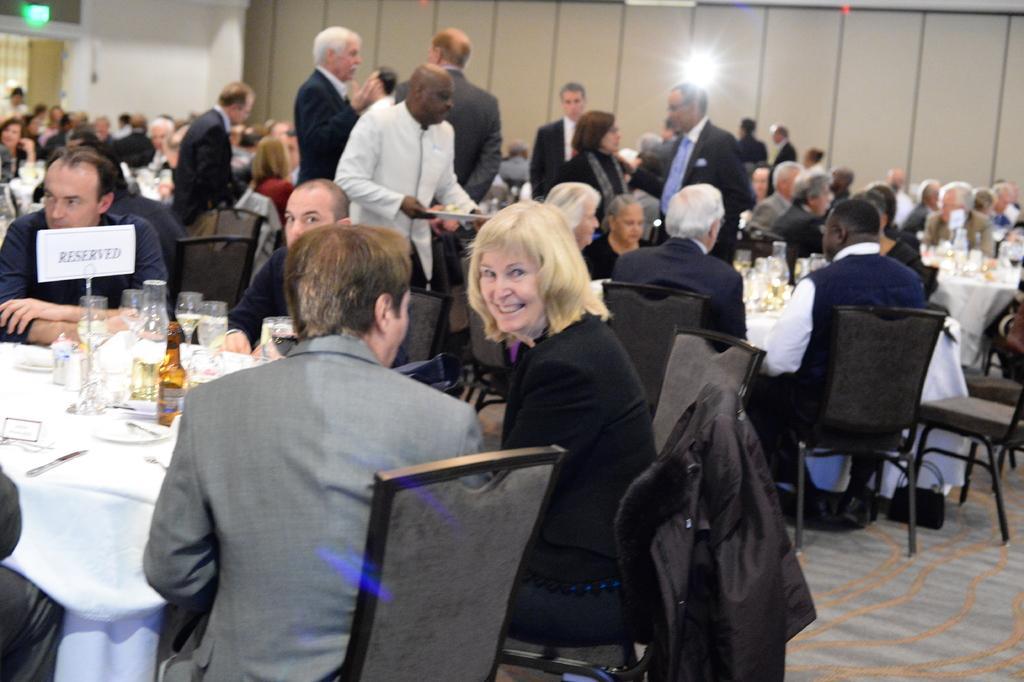Can you describe this image briefly? This image is taken inside a room, there were many people in this room, few of them were standing and few of them were sitting on a chairs. At the bottom of the image there is a floor with mat. At the left side of the image there is a table with a table cloth on it and there were few things on it like a bottle with wine, a glass of water, plates, knife and tissues. 